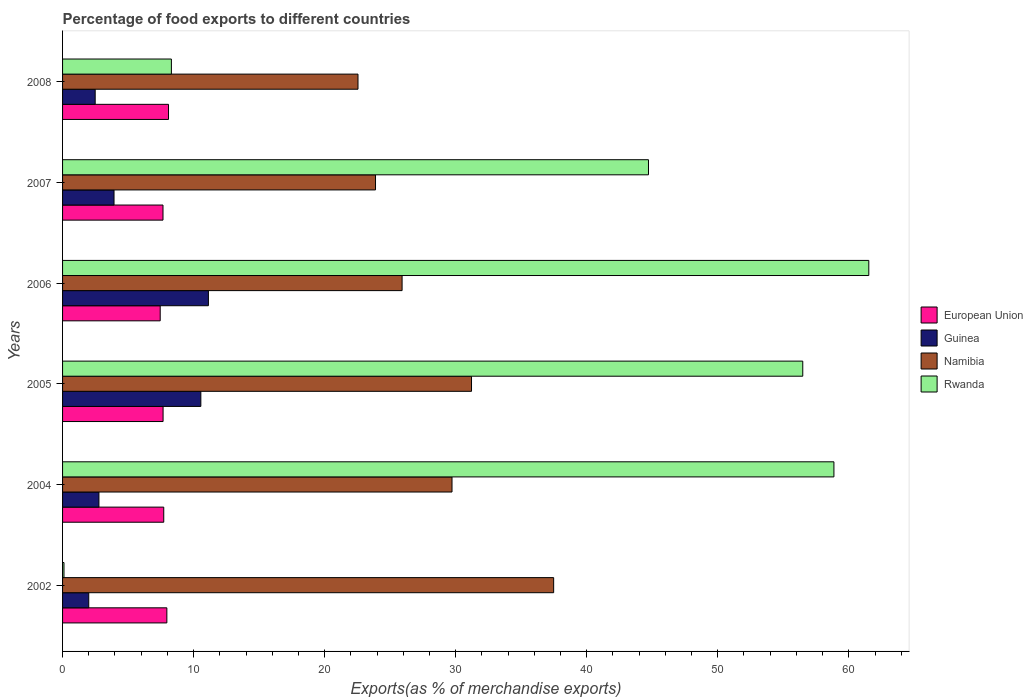How many different coloured bars are there?
Provide a succinct answer. 4. Are the number of bars per tick equal to the number of legend labels?
Give a very brief answer. Yes. How many bars are there on the 3rd tick from the top?
Your response must be concise. 4. What is the label of the 1st group of bars from the top?
Provide a succinct answer. 2008. In how many cases, is the number of bars for a given year not equal to the number of legend labels?
Your answer should be compact. 0. What is the percentage of exports to different countries in European Union in 2008?
Ensure brevity in your answer.  8.09. Across all years, what is the maximum percentage of exports to different countries in European Union?
Ensure brevity in your answer.  8.09. Across all years, what is the minimum percentage of exports to different countries in Guinea?
Ensure brevity in your answer.  2. In which year was the percentage of exports to different countries in Rwanda maximum?
Provide a succinct answer. 2006. What is the total percentage of exports to different countries in European Union in the graph?
Make the answer very short. 46.55. What is the difference between the percentage of exports to different countries in Namibia in 2002 and that in 2006?
Your response must be concise. 11.57. What is the difference between the percentage of exports to different countries in Rwanda in 2004 and the percentage of exports to different countries in Guinea in 2007?
Make the answer very short. 54.94. What is the average percentage of exports to different countries in Namibia per year?
Provide a succinct answer. 28.46. In the year 2005, what is the difference between the percentage of exports to different countries in Rwanda and percentage of exports to different countries in Guinea?
Your answer should be compact. 45.93. What is the ratio of the percentage of exports to different countries in Namibia in 2002 to that in 2007?
Your response must be concise. 1.57. What is the difference between the highest and the second highest percentage of exports to different countries in European Union?
Ensure brevity in your answer.  0.13. What is the difference between the highest and the lowest percentage of exports to different countries in Namibia?
Keep it short and to the point. 14.93. In how many years, is the percentage of exports to different countries in Rwanda greater than the average percentage of exports to different countries in Rwanda taken over all years?
Offer a terse response. 4. Is the sum of the percentage of exports to different countries in Namibia in 2005 and 2008 greater than the maximum percentage of exports to different countries in Guinea across all years?
Give a very brief answer. Yes. Is it the case that in every year, the sum of the percentage of exports to different countries in Namibia and percentage of exports to different countries in European Union is greater than the sum of percentage of exports to different countries in Rwanda and percentage of exports to different countries in Guinea?
Your response must be concise. Yes. What does the 3rd bar from the top in 2004 represents?
Ensure brevity in your answer.  Guinea. What does the 2nd bar from the bottom in 2007 represents?
Your answer should be very brief. Guinea. Is it the case that in every year, the sum of the percentage of exports to different countries in Namibia and percentage of exports to different countries in Rwanda is greater than the percentage of exports to different countries in Guinea?
Give a very brief answer. Yes. Are all the bars in the graph horizontal?
Your response must be concise. Yes. What is the difference between two consecutive major ticks on the X-axis?
Keep it short and to the point. 10. How many legend labels are there?
Offer a terse response. 4. How are the legend labels stacked?
Make the answer very short. Vertical. What is the title of the graph?
Offer a very short reply. Percentage of food exports to different countries. What is the label or title of the X-axis?
Give a very brief answer. Exports(as % of merchandise exports). What is the Exports(as % of merchandise exports) of European Union in 2002?
Offer a terse response. 7.96. What is the Exports(as % of merchandise exports) of Guinea in 2002?
Ensure brevity in your answer.  2. What is the Exports(as % of merchandise exports) in Namibia in 2002?
Your answer should be very brief. 37.48. What is the Exports(as % of merchandise exports) in Rwanda in 2002?
Keep it short and to the point. 0.11. What is the Exports(as % of merchandise exports) in European Union in 2004?
Keep it short and to the point. 7.72. What is the Exports(as % of merchandise exports) in Guinea in 2004?
Your response must be concise. 2.78. What is the Exports(as % of merchandise exports) of Namibia in 2004?
Give a very brief answer. 29.72. What is the Exports(as % of merchandise exports) of Rwanda in 2004?
Provide a short and direct response. 58.86. What is the Exports(as % of merchandise exports) in European Union in 2005?
Keep it short and to the point. 7.67. What is the Exports(as % of merchandise exports) in Guinea in 2005?
Give a very brief answer. 10.55. What is the Exports(as % of merchandise exports) in Namibia in 2005?
Offer a very short reply. 31.21. What is the Exports(as % of merchandise exports) of Rwanda in 2005?
Give a very brief answer. 56.49. What is the Exports(as % of merchandise exports) in European Union in 2006?
Keep it short and to the point. 7.45. What is the Exports(as % of merchandise exports) of Guinea in 2006?
Your response must be concise. 11.13. What is the Exports(as % of merchandise exports) of Namibia in 2006?
Offer a very short reply. 25.91. What is the Exports(as % of merchandise exports) of Rwanda in 2006?
Make the answer very short. 61.53. What is the Exports(as % of merchandise exports) of European Union in 2007?
Provide a succinct answer. 7.66. What is the Exports(as % of merchandise exports) of Guinea in 2007?
Provide a short and direct response. 3.93. What is the Exports(as % of merchandise exports) of Namibia in 2007?
Your answer should be very brief. 23.88. What is the Exports(as % of merchandise exports) in Rwanda in 2007?
Your answer should be very brief. 44.71. What is the Exports(as % of merchandise exports) in European Union in 2008?
Your answer should be compact. 8.09. What is the Exports(as % of merchandise exports) in Guinea in 2008?
Provide a succinct answer. 2.49. What is the Exports(as % of merchandise exports) in Namibia in 2008?
Ensure brevity in your answer.  22.55. What is the Exports(as % of merchandise exports) in Rwanda in 2008?
Make the answer very short. 8.3. Across all years, what is the maximum Exports(as % of merchandise exports) of European Union?
Offer a very short reply. 8.09. Across all years, what is the maximum Exports(as % of merchandise exports) of Guinea?
Make the answer very short. 11.13. Across all years, what is the maximum Exports(as % of merchandise exports) in Namibia?
Ensure brevity in your answer.  37.48. Across all years, what is the maximum Exports(as % of merchandise exports) of Rwanda?
Offer a very short reply. 61.53. Across all years, what is the minimum Exports(as % of merchandise exports) in European Union?
Give a very brief answer. 7.45. Across all years, what is the minimum Exports(as % of merchandise exports) in Guinea?
Ensure brevity in your answer.  2. Across all years, what is the minimum Exports(as % of merchandise exports) in Namibia?
Ensure brevity in your answer.  22.55. Across all years, what is the minimum Exports(as % of merchandise exports) of Rwanda?
Your response must be concise. 0.11. What is the total Exports(as % of merchandise exports) in European Union in the graph?
Offer a very short reply. 46.55. What is the total Exports(as % of merchandise exports) of Guinea in the graph?
Make the answer very short. 32.87. What is the total Exports(as % of merchandise exports) in Namibia in the graph?
Your response must be concise. 170.74. What is the total Exports(as % of merchandise exports) in Rwanda in the graph?
Ensure brevity in your answer.  230. What is the difference between the Exports(as % of merchandise exports) of European Union in 2002 and that in 2004?
Your answer should be compact. 0.24. What is the difference between the Exports(as % of merchandise exports) of Guinea in 2002 and that in 2004?
Offer a very short reply. -0.78. What is the difference between the Exports(as % of merchandise exports) of Namibia in 2002 and that in 2004?
Provide a succinct answer. 7.76. What is the difference between the Exports(as % of merchandise exports) of Rwanda in 2002 and that in 2004?
Provide a succinct answer. -58.76. What is the difference between the Exports(as % of merchandise exports) of European Union in 2002 and that in 2005?
Offer a terse response. 0.29. What is the difference between the Exports(as % of merchandise exports) in Guinea in 2002 and that in 2005?
Give a very brief answer. -8.55. What is the difference between the Exports(as % of merchandise exports) in Namibia in 2002 and that in 2005?
Your answer should be compact. 6.27. What is the difference between the Exports(as % of merchandise exports) in Rwanda in 2002 and that in 2005?
Your answer should be compact. -56.38. What is the difference between the Exports(as % of merchandise exports) in European Union in 2002 and that in 2006?
Make the answer very short. 0.51. What is the difference between the Exports(as % of merchandise exports) in Guinea in 2002 and that in 2006?
Your answer should be compact. -9.13. What is the difference between the Exports(as % of merchandise exports) in Namibia in 2002 and that in 2006?
Provide a short and direct response. 11.57. What is the difference between the Exports(as % of merchandise exports) of Rwanda in 2002 and that in 2006?
Make the answer very short. -61.42. What is the difference between the Exports(as % of merchandise exports) in European Union in 2002 and that in 2007?
Make the answer very short. 0.29. What is the difference between the Exports(as % of merchandise exports) of Guinea in 2002 and that in 2007?
Offer a very short reply. -1.93. What is the difference between the Exports(as % of merchandise exports) of Namibia in 2002 and that in 2007?
Give a very brief answer. 13.59. What is the difference between the Exports(as % of merchandise exports) of Rwanda in 2002 and that in 2007?
Your response must be concise. -44.6. What is the difference between the Exports(as % of merchandise exports) in European Union in 2002 and that in 2008?
Make the answer very short. -0.13. What is the difference between the Exports(as % of merchandise exports) in Guinea in 2002 and that in 2008?
Give a very brief answer. -0.49. What is the difference between the Exports(as % of merchandise exports) in Namibia in 2002 and that in 2008?
Make the answer very short. 14.93. What is the difference between the Exports(as % of merchandise exports) of Rwanda in 2002 and that in 2008?
Your response must be concise. -8.2. What is the difference between the Exports(as % of merchandise exports) in European Union in 2004 and that in 2005?
Your answer should be very brief. 0.05. What is the difference between the Exports(as % of merchandise exports) of Guinea in 2004 and that in 2005?
Your response must be concise. -7.78. What is the difference between the Exports(as % of merchandise exports) of Namibia in 2004 and that in 2005?
Ensure brevity in your answer.  -1.49. What is the difference between the Exports(as % of merchandise exports) in Rwanda in 2004 and that in 2005?
Offer a terse response. 2.38. What is the difference between the Exports(as % of merchandise exports) in European Union in 2004 and that in 2006?
Your answer should be compact. 0.27. What is the difference between the Exports(as % of merchandise exports) in Guinea in 2004 and that in 2006?
Offer a terse response. -8.35. What is the difference between the Exports(as % of merchandise exports) of Namibia in 2004 and that in 2006?
Give a very brief answer. 3.81. What is the difference between the Exports(as % of merchandise exports) in Rwanda in 2004 and that in 2006?
Your response must be concise. -2.66. What is the difference between the Exports(as % of merchandise exports) of European Union in 2004 and that in 2007?
Your answer should be very brief. 0.06. What is the difference between the Exports(as % of merchandise exports) of Guinea in 2004 and that in 2007?
Provide a succinct answer. -1.15. What is the difference between the Exports(as % of merchandise exports) in Namibia in 2004 and that in 2007?
Keep it short and to the point. 5.84. What is the difference between the Exports(as % of merchandise exports) in Rwanda in 2004 and that in 2007?
Give a very brief answer. 14.15. What is the difference between the Exports(as % of merchandise exports) of European Union in 2004 and that in 2008?
Your answer should be compact. -0.36. What is the difference between the Exports(as % of merchandise exports) in Guinea in 2004 and that in 2008?
Make the answer very short. 0.29. What is the difference between the Exports(as % of merchandise exports) of Namibia in 2004 and that in 2008?
Ensure brevity in your answer.  7.17. What is the difference between the Exports(as % of merchandise exports) of Rwanda in 2004 and that in 2008?
Your response must be concise. 50.56. What is the difference between the Exports(as % of merchandise exports) in European Union in 2005 and that in 2006?
Offer a terse response. 0.22. What is the difference between the Exports(as % of merchandise exports) of Guinea in 2005 and that in 2006?
Provide a succinct answer. -0.58. What is the difference between the Exports(as % of merchandise exports) in Namibia in 2005 and that in 2006?
Your answer should be very brief. 5.3. What is the difference between the Exports(as % of merchandise exports) of Rwanda in 2005 and that in 2006?
Offer a very short reply. -5.04. What is the difference between the Exports(as % of merchandise exports) of European Union in 2005 and that in 2007?
Ensure brevity in your answer.  0.01. What is the difference between the Exports(as % of merchandise exports) of Guinea in 2005 and that in 2007?
Ensure brevity in your answer.  6.63. What is the difference between the Exports(as % of merchandise exports) in Namibia in 2005 and that in 2007?
Ensure brevity in your answer.  7.33. What is the difference between the Exports(as % of merchandise exports) of Rwanda in 2005 and that in 2007?
Provide a succinct answer. 11.77. What is the difference between the Exports(as % of merchandise exports) in European Union in 2005 and that in 2008?
Give a very brief answer. -0.42. What is the difference between the Exports(as % of merchandise exports) in Guinea in 2005 and that in 2008?
Ensure brevity in your answer.  8.06. What is the difference between the Exports(as % of merchandise exports) in Namibia in 2005 and that in 2008?
Give a very brief answer. 8.66. What is the difference between the Exports(as % of merchandise exports) in Rwanda in 2005 and that in 2008?
Give a very brief answer. 48.18. What is the difference between the Exports(as % of merchandise exports) of European Union in 2006 and that in 2007?
Provide a succinct answer. -0.21. What is the difference between the Exports(as % of merchandise exports) in Guinea in 2006 and that in 2007?
Keep it short and to the point. 7.2. What is the difference between the Exports(as % of merchandise exports) of Namibia in 2006 and that in 2007?
Give a very brief answer. 2.03. What is the difference between the Exports(as % of merchandise exports) of Rwanda in 2006 and that in 2007?
Offer a very short reply. 16.81. What is the difference between the Exports(as % of merchandise exports) of European Union in 2006 and that in 2008?
Your answer should be compact. -0.64. What is the difference between the Exports(as % of merchandise exports) in Guinea in 2006 and that in 2008?
Offer a very short reply. 8.64. What is the difference between the Exports(as % of merchandise exports) of Namibia in 2006 and that in 2008?
Make the answer very short. 3.36. What is the difference between the Exports(as % of merchandise exports) in Rwanda in 2006 and that in 2008?
Keep it short and to the point. 53.22. What is the difference between the Exports(as % of merchandise exports) in European Union in 2007 and that in 2008?
Keep it short and to the point. -0.42. What is the difference between the Exports(as % of merchandise exports) of Guinea in 2007 and that in 2008?
Ensure brevity in your answer.  1.44. What is the difference between the Exports(as % of merchandise exports) of Namibia in 2007 and that in 2008?
Offer a very short reply. 1.34. What is the difference between the Exports(as % of merchandise exports) of Rwanda in 2007 and that in 2008?
Your answer should be very brief. 36.41. What is the difference between the Exports(as % of merchandise exports) of European Union in 2002 and the Exports(as % of merchandise exports) of Guinea in 2004?
Offer a terse response. 5.18. What is the difference between the Exports(as % of merchandise exports) of European Union in 2002 and the Exports(as % of merchandise exports) of Namibia in 2004?
Give a very brief answer. -21.76. What is the difference between the Exports(as % of merchandise exports) of European Union in 2002 and the Exports(as % of merchandise exports) of Rwanda in 2004?
Make the answer very short. -50.91. What is the difference between the Exports(as % of merchandise exports) of Guinea in 2002 and the Exports(as % of merchandise exports) of Namibia in 2004?
Make the answer very short. -27.72. What is the difference between the Exports(as % of merchandise exports) of Guinea in 2002 and the Exports(as % of merchandise exports) of Rwanda in 2004?
Provide a succinct answer. -56.87. What is the difference between the Exports(as % of merchandise exports) of Namibia in 2002 and the Exports(as % of merchandise exports) of Rwanda in 2004?
Offer a very short reply. -21.39. What is the difference between the Exports(as % of merchandise exports) of European Union in 2002 and the Exports(as % of merchandise exports) of Guinea in 2005?
Give a very brief answer. -2.59. What is the difference between the Exports(as % of merchandise exports) in European Union in 2002 and the Exports(as % of merchandise exports) in Namibia in 2005?
Give a very brief answer. -23.25. What is the difference between the Exports(as % of merchandise exports) of European Union in 2002 and the Exports(as % of merchandise exports) of Rwanda in 2005?
Ensure brevity in your answer.  -48.53. What is the difference between the Exports(as % of merchandise exports) in Guinea in 2002 and the Exports(as % of merchandise exports) in Namibia in 2005?
Offer a very short reply. -29.21. What is the difference between the Exports(as % of merchandise exports) in Guinea in 2002 and the Exports(as % of merchandise exports) in Rwanda in 2005?
Your response must be concise. -54.49. What is the difference between the Exports(as % of merchandise exports) of Namibia in 2002 and the Exports(as % of merchandise exports) of Rwanda in 2005?
Provide a succinct answer. -19.01. What is the difference between the Exports(as % of merchandise exports) in European Union in 2002 and the Exports(as % of merchandise exports) in Guinea in 2006?
Provide a short and direct response. -3.17. What is the difference between the Exports(as % of merchandise exports) of European Union in 2002 and the Exports(as % of merchandise exports) of Namibia in 2006?
Offer a very short reply. -17.95. What is the difference between the Exports(as % of merchandise exports) in European Union in 2002 and the Exports(as % of merchandise exports) in Rwanda in 2006?
Provide a short and direct response. -53.57. What is the difference between the Exports(as % of merchandise exports) in Guinea in 2002 and the Exports(as % of merchandise exports) in Namibia in 2006?
Offer a very short reply. -23.91. What is the difference between the Exports(as % of merchandise exports) of Guinea in 2002 and the Exports(as % of merchandise exports) of Rwanda in 2006?
Your answer should be very brief. -59.53. What is the difference between the Exports(as % of merchandise exports) in Namibia in 2002 and the Exports(as % of merchandise exports) in Rwanda in 2006?
Provide a short and direct response. -24.05. What is the difference between the Exports(as % of merchandise exports) of European Union in 2002 and the Exports(as % of merchandise exports) of Guinea in 2007?
Offer a terse response. 4.03. What is the difference between the Exports(as % of merchandise exports) in European Union in 2002 and the Exports(as % of merchandise exports) in Namibia in 2007?
Your response must be concise. -15.92. What is the difference between the Exports(as % of merchandise exports) of European Union in 2002 and the Exports(as % of merchandise exports) of Rwanda in 2007?
Provide a succinct answer. -36.75. What is the difference between the Exports(as % of merchandise exports) of Guinea in 2002 and the Exports(as % of merchandise exports) of Namibia in 2007?
Ensure brevity in your answer.  -21.88. What is the difference between the Exports(as % of merchandise exports) of Guinea in 2002 and the Exports(as % of merchandise exports) of Rwanda in 2007?
Keep it short and to the point. -42.71. What is the difference between the Exports(as % of merchandise exports) in Namibia in 2002 and the Exports(as % of merchandise exports) in Rwanda in 2007?
Your answer should be compact. -7.24. What is the difference between the Exports(as % of merchandise exports) of European Union in 2002 and the Exports(as % of merchandise exports) of Guinea in 2008?
Your answer should be very brief. 5.47. What is the difference between the Exports(as % of merchandise exports) of European Union in 2002 and the Exports(as % of merchandise exports) of Namibia in 2008?
Give a very brief answer. -14.59. What is the difference between the Exports(as % of merchandise exports) of European Union in 2002 and the Exports(as % of merchandise exports) of Rwanda in 2008?
Give a very brief answer. -0.35. What is the difference between the Exports(as % of merchandise exports) in Guinea in 2002 and the Exports(as % of merchandise exports) in Namibia in 2008?
Keep it short and to the point. -20.55. What is the difference between the Exports(as % of merchandise exports) in Guinea in 2002 and the Exports(as % of merchandise exports) in Rwanda in 2008?
Your response must be concise. -6.31. What is the difference between the Exports(as % of merchandise exports) of Namibia in 2002 and the Exports(as % of merchandise exports) of Rwanda in 2008?
Offer a terse response. 29.17. What is the difference between the Exports(as % of merchandise exports) in European Union in 2004 and the Exports(as % of merchandise exports) in Guinea in 2005?
Provide a short and direct response. -2.83. What is the difference between the Exports(as % of merchandise exports) in European Union in 2004 and the Exports(as % of merchandise exports) in Namibia in 2005?
Keep it short and to the point. -23.49. What is the difference between the Exports(as % of merchandise exports) of European Union in 2004 and the Exports(as % of merchandise exports) of Rwanda in 2005?
Give a very brief answer. -48.77. What is the difference between the Exports(as % of merchandise exports) in Guinea in 2004 and the Exports(as % of merchandise exports) in Namibia in 2005?
Provide a short and direct response. -28.43. What is the difference between the Exports(as % of merchandise exports) of Guinea in 2004 and the Exports(as % of merchandise exports) of Rwanda in 2005?
Make the answer very short. -53.71. What is the difference between the Exports(as % of merchandise exports) of Namibia in 2004 and the Exports(as % of merchandise exports) of Rwanda in 2005?
Give a very brief answer. -26.77. What is the difference between the Exports(as % of merchandise exports) of European Union in 2004 and the Exports(as % of merchandise exports) of Guinea in 2006?
Your answer should be very brief. -3.41. What is the difference between the Exports(as % of merchandise exports) in European Union in 2004 and the Exports(as % of merchandise exports) in Namibia in 2006?
Make the answer very short. -18.19. What is the difference between the Exports(as % of merchandise exports) in European Union in 2004 and the Exports(as % of merchandise exports) in Rwanda in 2006?
Give a very brief answer. -53.8. What is the difference between the Exports(as % of merchandise exports) of Guinea in 2004 and the Exports(as % of merchandise exports) of Namibia in 2006?
Provide a succinct answer. -23.13. What is the difference between the Exports(as % of merchandise exports) in Guinea in 2004 and the Exports(as % of merchandise exports) in Rwanda in 2006?
Your answer should be very brief. -58.75. What is the difference between the Exports(as % of merchandise exports) of Namibia in 2004 and the Exports(as % of merchandise exports) of Rwanda in 2006?
Make the answer very short. -31.81. What is the difference between the Exports(as % of merchandise exports) in European Union in 2004 and the Exports(as % of merchandise exports) in Guinea in 2007?
Provide a short and direct response. 3.79. What is the difference between the Exports(as % of merchandise exports) in European Union in 2004 and the Exports(as % of merchandise exports) in Namibia in 2007?
Give a very brief answer. -16.16. What is the difference between the Exports(as % of merchandise exports) of European Union in 2004 and the Exports(as % of merchandise exports) of Rwanda in 2007?
Offer a terse response. -36.99. What is the difference between the Exports(as % of merchandise exports) of Guinea in 2004 and the Exports(as % of merchandise exports) of Namibia in 2007?
Keep it short and to the point. -21.11. What is the difference between the Exports(as % of merchandise exports) in Guinea in 2004 and the Exports(as % of merchandise exports) in Rwanda in 2007?
Your answer should be compact. -41.94. What is the difference between the Exports(as % of merchandise exports) of Namibia in 2004 and the Exports(as % of merchandise exports) of Rwanda in 2007?
Your answer should be very brief. -14.99. What is the difference between the Exports(as % of merchandise exports) in European Union in 2004 and the Exports(as % of merchandise exports) in Guinea in 2008?
Keep it short and to the point. 5.23. What is the difference between the Exports(as % of merchandise exports) in European Union in 2004 and the Exports(as % of merchandise exports) in Namibia in 2008?
Make the answer very short. -14.82. What is the difference between the Exports(as % of merchandise exports) in European Union in 2004 and the Exports(as % of merchandise exports) in Rwanda in 2008?
Your answer should be very brief. -0.58. What is the difference between the Exports(as % of merchandise exports) in Guinea in 2004 and the Exports(as % of merchandise exports) in Namibia in 2008?
Give a very brief answer. -19.77. What is the difference between the Exports(as % of merchandise exports) of Guinea in 2004 and the Exports(as % of merchandise exports) of Rwanda in 2008?
Provide a short and direct response. -5.53. What is the difference between the Exports(as % of merchandise exports) of Namibia in 2004 and the Exports(as % of merchandise exports) of Rwanda in 2008?
Keep it short and to the point. 21.41. What is the difference between the Exports(as % of merchandise exports) in European Union in 2005 and the Exports(as % of merchandise exports) in Guinea in 2006?
Your answer should be compact. -3.46. What is the difference between the Exports(as % of merchandise exports) of European Union in 2005 and the Exports(as % of merchandise exports) of Namibia in 2006?
Provide a short and direct response. -18.24. What is the difference between the Exports(as % of merchandise exports) in European Union in 2005 and the Exports(as % of merchandise exports) in Rwanda in 2006?
Provide a short and direct response. -53.85. What is the difference between the Exports(as % of merchandise exports) of Guinea in 2005 and the Exports(as % of merchandise exports) of Namibia in 2006?
Offer a very short reply. -15.36. What is the difference between the Exports(as % of merchandise exports) in Guinea in 2005 and the Exports(as % of merchandise exports) in Rwanda in 2006?
Offer a terse response. -50.97. What is the difference between the Exports(as % of merchandise exports) in Namibia in 2005 and the Exports(as % of merchandise exports) in Rwanda in 2006?
Offer a terse response. -30.32. What is the difference between the Exports(as % of merchandise exports) of European Union in 2005 and the Exports(as % of merchandise exports) of Guinea in 2007?
Make the answer very short. 3.74. What is the difference between the Exports(as % of merchandise exports) in European Union in 2005 and the Exports(as % of merchandise exports) in Namibia in 2007?
Provide a succinct answer. -16.21. What is the difference between the Exports(as % of merchandise exports) in European Union in 2005 and the Exports(as % of merchandise exports) in Rwanda in 2007?
Your response must be concise. -37.04. What is the difference between the Exports(as % of merchandise exports) of Guinea in 2005 and the Exports(as % of merchandise exports) of Namibia in 2007?
Your answer should be very brief. -13.33. What is the difference between the Exports(as % of merchandise exports) of Guinea in 2005 and the Exports(as % of merchandise exports) of Rwanda in 2007?
Your answer should be compact. -34.16. What is the difference between the Exports(as % of merchandise exports) of Namibia in 2005 and the Exports(as % of merchandise exports) of Rwanda in 2007?
Your answer should be very brief. -13.5. What is the difference between the Exports(as % of merchandise exports) in European Union in 2005 and the Exports(as % of merchandise exports) in Guinea in 2008?
Give a very brief answer. 5.18. What is the difference between the Exports(as % of merchandise exports) of European Union in 2005 and the Exports(as % of merchandise exports) of Namibia in 2008?
Your answer should be compact. -14.87. What is the difference between the Exports(as % of merchandise exports) of European Union in 2005 and the Exports(as % of merchandise exports) of Rwanda in 2008?
Provide a short and direct response. -0.63. What is the difference between the Exports(as % of merchandise exports) of Guinea in 2005 and the Exports(as % of merchandise exports) of Namibia in 2008?
Your answer should be compact. -11.99. What is the difference between the Exports(as % of merchandise exports) of Guinea in 2005 and the Exports(as % of merchandise exports) of Rwanda in 2008?
Provide a short and direct response. 2.25. What is the difference between the Exports(as % of merchandise exports) in Namibia in 2005 and the Exports(as % of merchandise exports) in Rwanda in 2008?
Ensure brevity in your answer.  22.9. What is the difference between the Exports(as % of merchandise exports) in European Union in 2006 and the Exports(as % of merchandise exports) in Guinea in 2007?
Offer a very short reply. 3.52. What is the difference between the Exports(as % of merchandise exports) in European Union in 2006 and the Exports(as % of merchandise exports) in Namibia in 2007?
Your answer should be compact. -16.43. What is the difference between the Exports(as % of merchandise exports) in European Union in 2006 and the Exports(as % of merchandise exports) in Rwanda in 2007?
Provide a succinct answer. -37.26. What is the difference between the Exports(as % of merchandise exports) in Guinea in 2006 and the Exports(as % of merchandise exports) in Namibia in 2007?
Your answer should be compact. -12.75. What is the difference between the Exports(as % of merchandise exports) of Guinea in 2006 and the Exports(as % of merchandise exports) of Rwanda in 2007?
Offer a terse response. -33.58. What is the difference between the Exports(as % of merchandise exports) in Namibia in 2006 and the Exports(as % of merchandise exports) in Rwanda in 2007?
Ensure brevity in your answer.  -18.8. What is the difference between the Exports(as % of merchandise exports) in European Union in 2006 and the Exports(as % of merchandise exports) in Guinea in 2008?
Provide a short and direct response. 4.96. What is the difference between the Exports(as % of merchandise exports) in European Union in 2006 and the Exports(as % of merchandise exports) in Namibia in 2008?
Ensure brevity in your answer.  -15.09. What is the difference between the Exports(as % of merchandise exports) of European Union in 2006 and the Exports(as % of merchandise exports) of Rwanda in 2008?
Make the answer very short. -0.85. What is the difference between the Exports(as % of merchandise exports) of Guinea in 2006 and the Exports(as % of merchandise exports) of Namibia in 2008?
Ensure brevity in your answer.  -11.42. What is the difference between the Exports(as % of merchandise exports) of Guinea in 2006 and the Exports(as % of merchandise exports) of Rwanda in 2008?
Offer a terse response. 2.83. What is the difference between the Exports(as % of merchandise exports) of Namibia in 2006 and the Exports(as % of merchandise exports) of Rwanda in 2008?
Give a very brief answer. 17.61. What is the difference between the Exports(as % of merchandise exports) in European Union in 2007 and the Exports(as % of merchandise exports) in Guinea in 2008?
Provide a succinct answer. 5.18. What is the difference between the Exports(as % of merchandise exports) in European Union in 2007 and the Exports(as % of merchandise exports) in Namibia in 2008?
Provide a succinct answer. -14.88. What is the difference between the Exports(as % of merchandise exports) in European Union in 2007 and the Exports(as % of merchandise exports) in Rwanda in 2008?
Your answer should be compact. -0.64. What is the difference between the Exports(as % of merchandise exports) in Guinea in 2007 and the Exports(as % of merchandise exports) in Namibia in 2008?
Keep it short and to the point. -18.62. What is the difference between the Exports(as % of merchandise exports) of Guinea in 2007 and the Exports(as % of merchandise exports) of Rwanda in 2008?
Provide a short and direct response. -4.38. What is the difference between the Exports(as % of merchandise exports) in Namibia in 2007 and the Exports(as % of merchandise exports) in Rwanda in 2008?
Your answer should be compact. 15.58. What is the average Exports(as % of merchandise exports) of European Union per year?
Keep it short and to the point. 7.76. What is the average Exports(as % of merchandise exports) in Guinea per year?
Your answer should be very brief. 5.48. What is the average Exports(as % of merchandise exports) of Namibia per year?
Offer a very short reply. 28.46. What is the average Exports(as % of merchandise exports) in Rwanda per year?
Your answer should be very brief. 38.33. In the year 2002, what is the difference between the Exports(as % of merchandise exports) of European Union and Exports(as % of merchandise exports) of Guinea?
Your response must be concise. 5.96. In the year 2002, what is the difference between the Exports(as % of merchandise exports) of European Union and Exports(as % of merchandise exports) of Namibia?
Provide a succinct answer. -29.52. In the year 2002, what is the difference between the Exports(as % of merchandise exports) in European Union and Exports(as % of merchandise exports) in Rwanda?
Offer a terse response. 7.85. In the year 2002, what is the difference between the Exports(as % of merchandise exports) in Guinea and Exports(as % of merchandise exports) in Namibia?
Offer a terse response. -35.48. In the year 2002, what is the difference between the Exports(as % of merchandise exports) of Guinea and Exports(as % of merchandise exports) of Rwanda?
Ensure brevity in your answer.  1.89. In the year 2002, what is the difference between the Exports(as % of merchandise exports) in Namibia and Exports(as % of merchandise exports) in Rwanda?
Ensure brevity in your answer.  37.37. In the year 2004, what is the difference between the Exports(as % of merchandise exports) of European Union and Exports(as % of merchandise exports) of Guinea?
Offer a very short reply. 4.95. In the year 2004, what is the difference between the Exports(as % of merchandise exports) in European Union and Exports(as % of merchandise exports) in Namibia?
Your answer should be compact. -22. In the year 2004, what is the difference between the Exports(as % of merchandise exports) in European Union and Exports(as % of merchandise exports) in Rwanda?
Offer a terse response. -51.14. In the year 2004, what is the difference between the Exports(as % of merchandise exports) of Guinea and Exports(as % of merchandise exports) of Namibia?
Provide a succinct answer. -26.94. In the year 2004, what is the difference between the Exports(as % of merchandise exports) of Guinea and Exports(as % of merchandise exports) of Rwanda?
Provide a succinct answer. -56.09. In the year 2004, what is the difference between the Exports(as % of merchandise exports) of Namibia and Exports(as % of merchandise exports) of Rwanda?
Provide a short and direct response. -29.15. In the year 2005, what is the difference between the Exports(as % of merchandise exports) in European Union and Exports(as % of merchandise exports) in Guinea?
Your response must be concise. -2.88. In the year 2005, what is the difference between the Exports(as % of merchandise exports) of European Union and Exports(as % of merchandise exports) of Namibia?
Keep it short and to the point. -23.54. In the year 2005, what is the difference between the Exports(as % of merchandise exports) in European Union and Exports(as % of merchandise exports) in Rwanda?
Keep it short and to the point. -48.82. In the year 2005, what is the difference between the Exports(as % of merchandise exports) of Guinea and Exports(as % of merchandise exports) of Namibia?
Offer a very short reply. -20.66. In the year 2005, what is the difference between the Exports(as % of merchandise exports) in Guinea and Exports(as % of merchandise exports) in Rwanda?
Provide a succinct answer. -45.94. In the year 2005, what is the difference between the Exports(as % of merchandise exports) of Namibia and Exports(as % of merchandise exports) of Rwanda?
Your answer should be compact. -25.28. In the year 2006, what is the difference between the Exports(as % of merchandise exports) in European Union and Exports(as % of merchandise exports) in Guinea?
Your answer should be very brief. -3.68. In the year 2006, what is the difference between the Exports(as % of merchandise exports) in European Union and Exports(as % of merchandise exports) in Namibia?
Make the answer very short. -18.46. In the year 2006, what is the difference between the Exports(as % of merchandise exports) in European Union and Exports(as % of merchandise exports) in Rwanda?
Your response must be concise. -54.07. In the year 2006, what is the difference between the Exports(as % of merchandise exports) of Guinea and Exports(as % of merchandise exports) of Namibia?
Your answer should be very brief. -14.78. In the year 2006, what is the difference between the Exports(as % of merchandise exports) of Guinea and Exports(as % of merchandise exports) of Rwanda?
Make the answer very short. -50.4. In the year 2006, what is the difference between the Exports(as % of merchandise exports) of Namibia and Exports(as % of merchandise exports) of Rwanda?
Give a very brief answer. -35.62. In the year 2007, what is the difference between the Exports(as % of merchandise exports) of European Union and Exports(as % of merchandise exports) of Guinea?
Ensure brevity in your answer.  3.74. In the year 2007, what is the difference between the Exports(as % of merchandise exports) of European Union and Exports(as % of merchandise exports) of Namibia?
Provide a succinct answer. -16.22. In the year 2007, what is the difference between the Exports(as % of merchandise exports) of European Union and Exports(as % of merchandise exports) of Rwanda?
Provide a short and direct response. -37.05. In the year 2007, what is the difference between the Exports(as % of merchandise exports) of Guinea and Exports(as % of merchandise exports) of Namibia?
Your answer should be compact. -19.96. In the year 2007, what is the difference between the Exports(as % of merchandise exports) in Guinea and Exports(as % of merchandise exports) in Rwanda?
Provide a succinct answer. -40.79. In the year 2007, what is the difference between the Exports(as % of merchandise exports) in Namibia and Exports(as % of merchandise exports) in Rwanda?
Your answer should be compact. -20.83. In the year 2008, what is the difference between the Exports(as % of merchandise exports) in European Union and Exports(as % of merchandise exports) in Guinea?
Offer a terse response. 5.6. In the year 2008, what is the difference between the Exports(as % of merchandise exports) of European Union and Exports(as % of merchandise exports) of Namibia?
Ensure brevity in your answer.  -14.46. In the year 2008, what is the difference between the Exports(as % of merchandise exports) in European Union and Exports(as % of merchandise exports) in Rwanda?
Ensure brevity in your answer.  -0.22. In the year 2008, what is the difference between the Exports(as % of merchandise exports) of Guinea and Exports(as % of merchandise exports) of Namibia?
Offer a terse response. -20.06. In the year 2008, what is the difference between the Exports(as % of merchandise exports) of Guinea and Exports(as % of merchandise exports) of Rwanda?
Offer a terse response. -5.81. In the year 2008, what is the difference between the Exports(as % of merchandise exports) in Namibia and Exports(as % of merchandise exports) in Rwanda?
Offer a very short reply. 14.24. What is the ratio of the Exports(as % of merchandise exports) of European Union in 2002 to that in 2004?
Provide a succinct answer. 1.03. What is the ratio of the Exports(as % of merchandise exports) of Guinea in 2002 to that in 2004?
Offer a terse response. 0.72. What is the ratio of the Exports(as % of merchandise exports) in Namibia in 2002 to that in 2004?
Keep it short and to the point. 1.26. What is the ratio of the Exports(as % of merchandise exports) of Rwanda in 2002 to that in 2004?
Keep it short and to the point. 0. What is the ratio of the Exports(as % of merchandise exports) in European Union in 2002 to that in 2005?
Offer a terse response. 1.04. What is the ratio of the Exports(as % of merchandise exports) in Guinea in 2002 to that in 2005?
Your answer should be compact. 0.19. What is the ratio of the Exports(as % of merchandise exports) in Namibia in 2002 to that in 2005?
Keep it short and to the point. 1.2. What is the ratio of the Exports(as % of merchandise exports) in Rwanda in 2002 to that in 2005?
Your answer should be very brief. 0. What is the ratio of the Exports(as % of merchandise exports) in European Union in 2002 to that in 2006?
Keep it short and to the point. 1.07. What is the ratio of the Exports(as % of merchandise exports) of Guinea in 2002 to that in 2006?
Offer a terse response. 0.18. What is the ratio of the Exports(as % of merchandise exports) in Namibia in 2002 to that in 2006?
Provide a short and direct response. 1.45. What is the ratio of the Exports(as % of merchandise exports) of Rwanda in 2002 to that in 2006?
Ensure brevity in your answer.  0. What is the ratio of the Exports(as % of merchandise exports) of European Union in 2002 to that in 2007?
Your response must be concise. 1.04. What is the ratio of the Exports(as % of merchandise exports) in Guinea in 2002 to that in 2007?
Give a very brief answer. 0.51. What is the ratio of the Exports(as % of merchandise exports) of Namibia in 2002 to that in 2007?
Make the answer very short. 1.57. What is the ratio of the Exports(as % of merchandise exports) in Rwanda in 2002 to that in 2007?
Offer a very short reply. 0. What is the ratio of the Exports(as % of merchandise exports) of European Union in 2002 to that in 2008?
Your response must be concise. 0.98. What is the ratio of the Exports(as % of merchandise exports) of Guinea in 2002 to that in 2008?
Give a very brief answer. 0.8. What is the ratio of the Exports(as % of merchandise exports) of Namibia in 2002 to that in 2008?
Provide a short and direct response. 1.66. What is the ratio of the Exports(as % of merchandise exports) in Rwanda in 2002 to that in 2008?
Offer a very short reply. 0.01. What is the ratio of the Exports(as % of merchandise exports) in European Union in 2004 to that in 2005?
Your answer should be very brief. 1.01. What is the ratio of the Exports(as % of merchandise exports) of Guinea in 2004 to that in 2005?
Offer a terse response. 0.26. What is the ratio of the Exports(as % of merchandise exports) in Namibia in 2004 to that in 2005?
Offer a very short reply. 0.95. What is the ratio of the Exports(as % of merchandise exports) of Rwanda in 2004 to that in 2005?
Your response must be concise. 1.04. What is the ratio of the Exports(as % of merchandise exports) of European Union in 2004 to that in 2006?
Keep it short and to the point. 1.04. What is the ratio of the Exports(as % of merchandise exports) of Guinea in 2004 to that in 2006?
Offer a very short reply. 0.25. What is the ratio of the Exports(as % of merchandise exports) in Namibia in 2004 to that in 2006?
Offer a terse response. 1.15. What is the ratio of the Exports(as % of merchandise exports) of Rwanda in 2004 to that in 2006?
Keep it short and to the point. 0.96. What is the ratio of the Exports(as % of merchandise exports) in European Union in 2004 to that in 2007?
Your answer should be compact. 1.01. What is the ratio of the Exports(as % of merchandise exports) of Guinea in 2004 to that in 2007?
Ensure brevity in your answer.  0.71. What is the ratio of the Exports(as % of merchandise exports) of Namibia in 2004 to that in 2007?
Offer a terse response. 1.24. What is the ratio of the Exports(as % of merchandise exports) of Rwanda in 2004 to that in 2007?
Ensure brevity in your answer.  1.32. What is the ratio of the Exports(as % of merchandise exports) in European Union in 2004 to that in 2008?
Your answer should be very brief. 0.95. What is the ratio of the Exports(as % of merchandise exports) in Guinea in 2004 to that in 2008?
Your answer should be very brief. 1.11. What is the ratio of the Exports(as % of merchandise exports) of Namibia in 2004 to that in 2008?
Your answer should be compact. 1.32. What is the ratio of the Exports(as % of merchandise exports) of Rwanda in 2004 to that in 2008?
Offer a very short reply. 7.09. What is the ratio of the Exports(as % of merchandise exports) in European Union in 2005 to that in 2006?
Provide a succinct answer. 1.03. What is the ratio of the Exports(as % of merchandise exports) in Guinea in 2005 to that in 2006?
Your response must be concise. 0.95. What is the ratio of the Exports(as % of merchandise exports) in Namibia in 2005 to that in 2006?
Keep it short and to the point. 1.2. What is the ratio of the Exports(as % of merchandise exports) of Rwanda in 2005 to that in 2006?
Your answer should be compact. 0.92. What is the ratio of the Exports(as % of merchandise exports) in European Union in 2005 to that in 2007?
Offer a very short reply. 1. What is the ratio of the Exports(as % of merchandise exports) in Guinea in 2005 to that in 2007?
Offer a terse response. 2.69. What is the ratio of the Exports(as % of merchandise exports) of Namibia in 2005 to that in 2007?
Give a very brief answer. 1.31. What is the ratio of the Exports(as % of merchandise exports) in Rwanda in 2005 to that in 2007?
Keep it short and to the point. 1.26. What is the ratio of the Exports(as % of merchandise exports) in European Union in 2005 to that in 2008?
Provide a short and direct response. 0.95. What is the ratio of the Exports(as % of merchandise exports) in Guinea in 2005 to that in 2008?
Give a very brief answer. 4.24. What is the ratio of the Exports(as % of merchandise exports) in Namibia in 2005 to that in 2008?
Give a very brief answer. 1.38. What is the ratio of the Exports(as % of merchandise exports) in Rwanda in 2005 to that in 2008?
Offer a very short reply. 6.8. What is the ratio of the Exports(as % of merchandise exports) of European Union in 2006 to that in 2007?
Ensure brevity in your answer.  0.97. What is the ratio of the Exports(as % of merchandise exports) of Guinea in 2006 to that in 2007?
Give a very brief answer. 2.83. What is the ratio of the Exports(as % of merchandise exports) of Namibia in 2006 to that in 2007?
Offer a terse response. 1.08. What is the ratio of the Exports(as % of merchandise exports) of Rwanda in 2006 to that in 2007?
Offer a very short reply. 1.38. What is the ratio of the Exports(as % of merchandise exports) in European Union in 2006 to that in 2008?
Give a very brief answer. 0.92. What is the ratio of the Exports(as % of merchandise exports) in Guinea in 2006 to that in 2008?
Ensure brevity in your answer.  4.47. What is the ratio of the Exports(as % of merchandise exports) in Namibia in 2006 to that in 2008?
Provide a succinct answer. 1.15. What is the ratio of the Exports(as % of merchandise exports) in Rwanda in 2006 to that in 2008?
Provide a succinct answer. 7.41. What is the ratio of the Exports(as % of merchandise exports) of European Union in 2007 to that in 2008?
Offer a terse response. 0.95. What is the ratio of the Exports(as % of merchandise exports) in Guinea in 2007 to that in 2008?
Give a very brief answer. 1.58. What is the ratio of the Exports(as % of merchandise exports) in Namibia in 2007 to that in 2008?
Your response must be concise. 1.06. What is the ratio of the Exports(as % of merchandise exports) of Rwanda in 2007 to that in 2008?
Provide a short and direct response. 5.38. What is the difference between the highest and the second highest Exports(as % of merchandise exports) of European Union?
Your answer should be very brief. 0.13. What is the difference between the highest and the second highest Exports(as % of merchandise exports) of Guinea?
Your answer should be compact. 0.58. What is the difference between the highest and the second highest Exports(as % of merchandise exports) of Namibia?
Your answer should be compact. 6.27. What is the difference between the highest and the second highest Exports(as % of merchandise exports) in Rwanda?
Your answer should be compact. 2.66. What is the difference between the highest and the lowest Exports(as % of merchandise exports) of European Union?
Provide a succinct answer. 0.64. What is the difference between the highest and the lowest Exports(as % of merchandise exports) of Guinea?
Provide a succinct answer. 9.13. What is the difference between the highest and the lowest Exports(as % of merchandise exports) of Namibia?
Offer a terse response. 14.93. What is the difference between the highest and the lowest Exports(as % of merchandise exports) in Rwanda?
Ensure brevity in your answer.  61.42. 